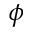Convert formula to latex. <formula><loc_0><loc_0><loc_500><loc_500>\phi</formula> 